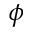Convert formula to latex. <formula><loc_0><loc_0><loc_500><loc_500>\phi</formula> 